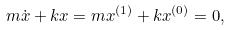<formula> <loc_0><loc_0><loc_500><loc_500>m \dot { x } + k x = m x ^ { ( 1 ) } + k x ^ { ( 0 ) } = 0 ,</formula> 